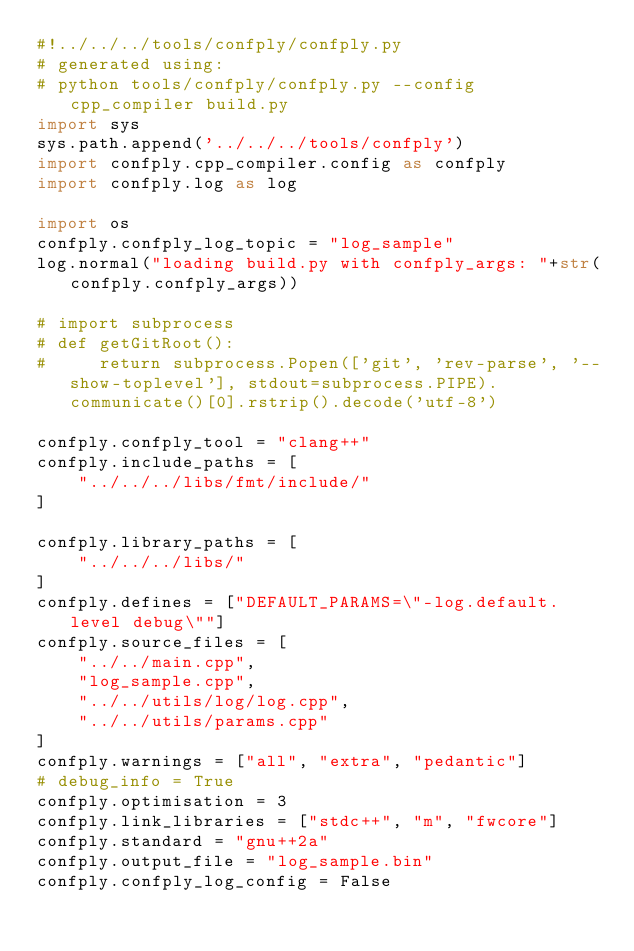Convert code to text. <code><loc_0><loc_0><loc_500><loc_500><_Python_>#!../../../tools/confply/confply.py
# generated using:
# python tools/confply/confply.py --config cpp_compiler build.py
import sys
sys.path.append('../../../tools/confply')
import confply.cpp_compiler.config as confply
import confply.log as log

import os
confply.confply_log_topic = "log_sample"
log.normal("loading build.py with confply_args: "+str(confply.confply_args))

# import subprocess
# def getGitRoot():
#     return subprocess.Popen(['git', 'rev-parse', '--show-toplevel'], stdout=subprocess.PIPE).communicate()[0].rstrip().decode('utf-8')

confply.confply_tool = "clang++"
confply.include_paths = [
    "../../../libs/fmt/include/"
]

confply.library_paths = [
    "../../../libs/"
]
confply.defines = ["DEFAULT_PARAMS=\"-log.default.level debug\""]
confply.source_files = [
    "../../main.cpp",
    "log_sample.cpp",
    "../../utils/log/log.cpp",
    "../../utils/params.cpp"
]
confply.warnings = ["all", "extra", "pedantic"]
# debug_info = True
confply.optimisation = 3
confply.link_libraries = ["stdc++", "m", "fwcore"]
confply.standard = "gnu++2a"
confply.output_file = "log_sample.bin"
confply.confply_log_config = False
</code> 